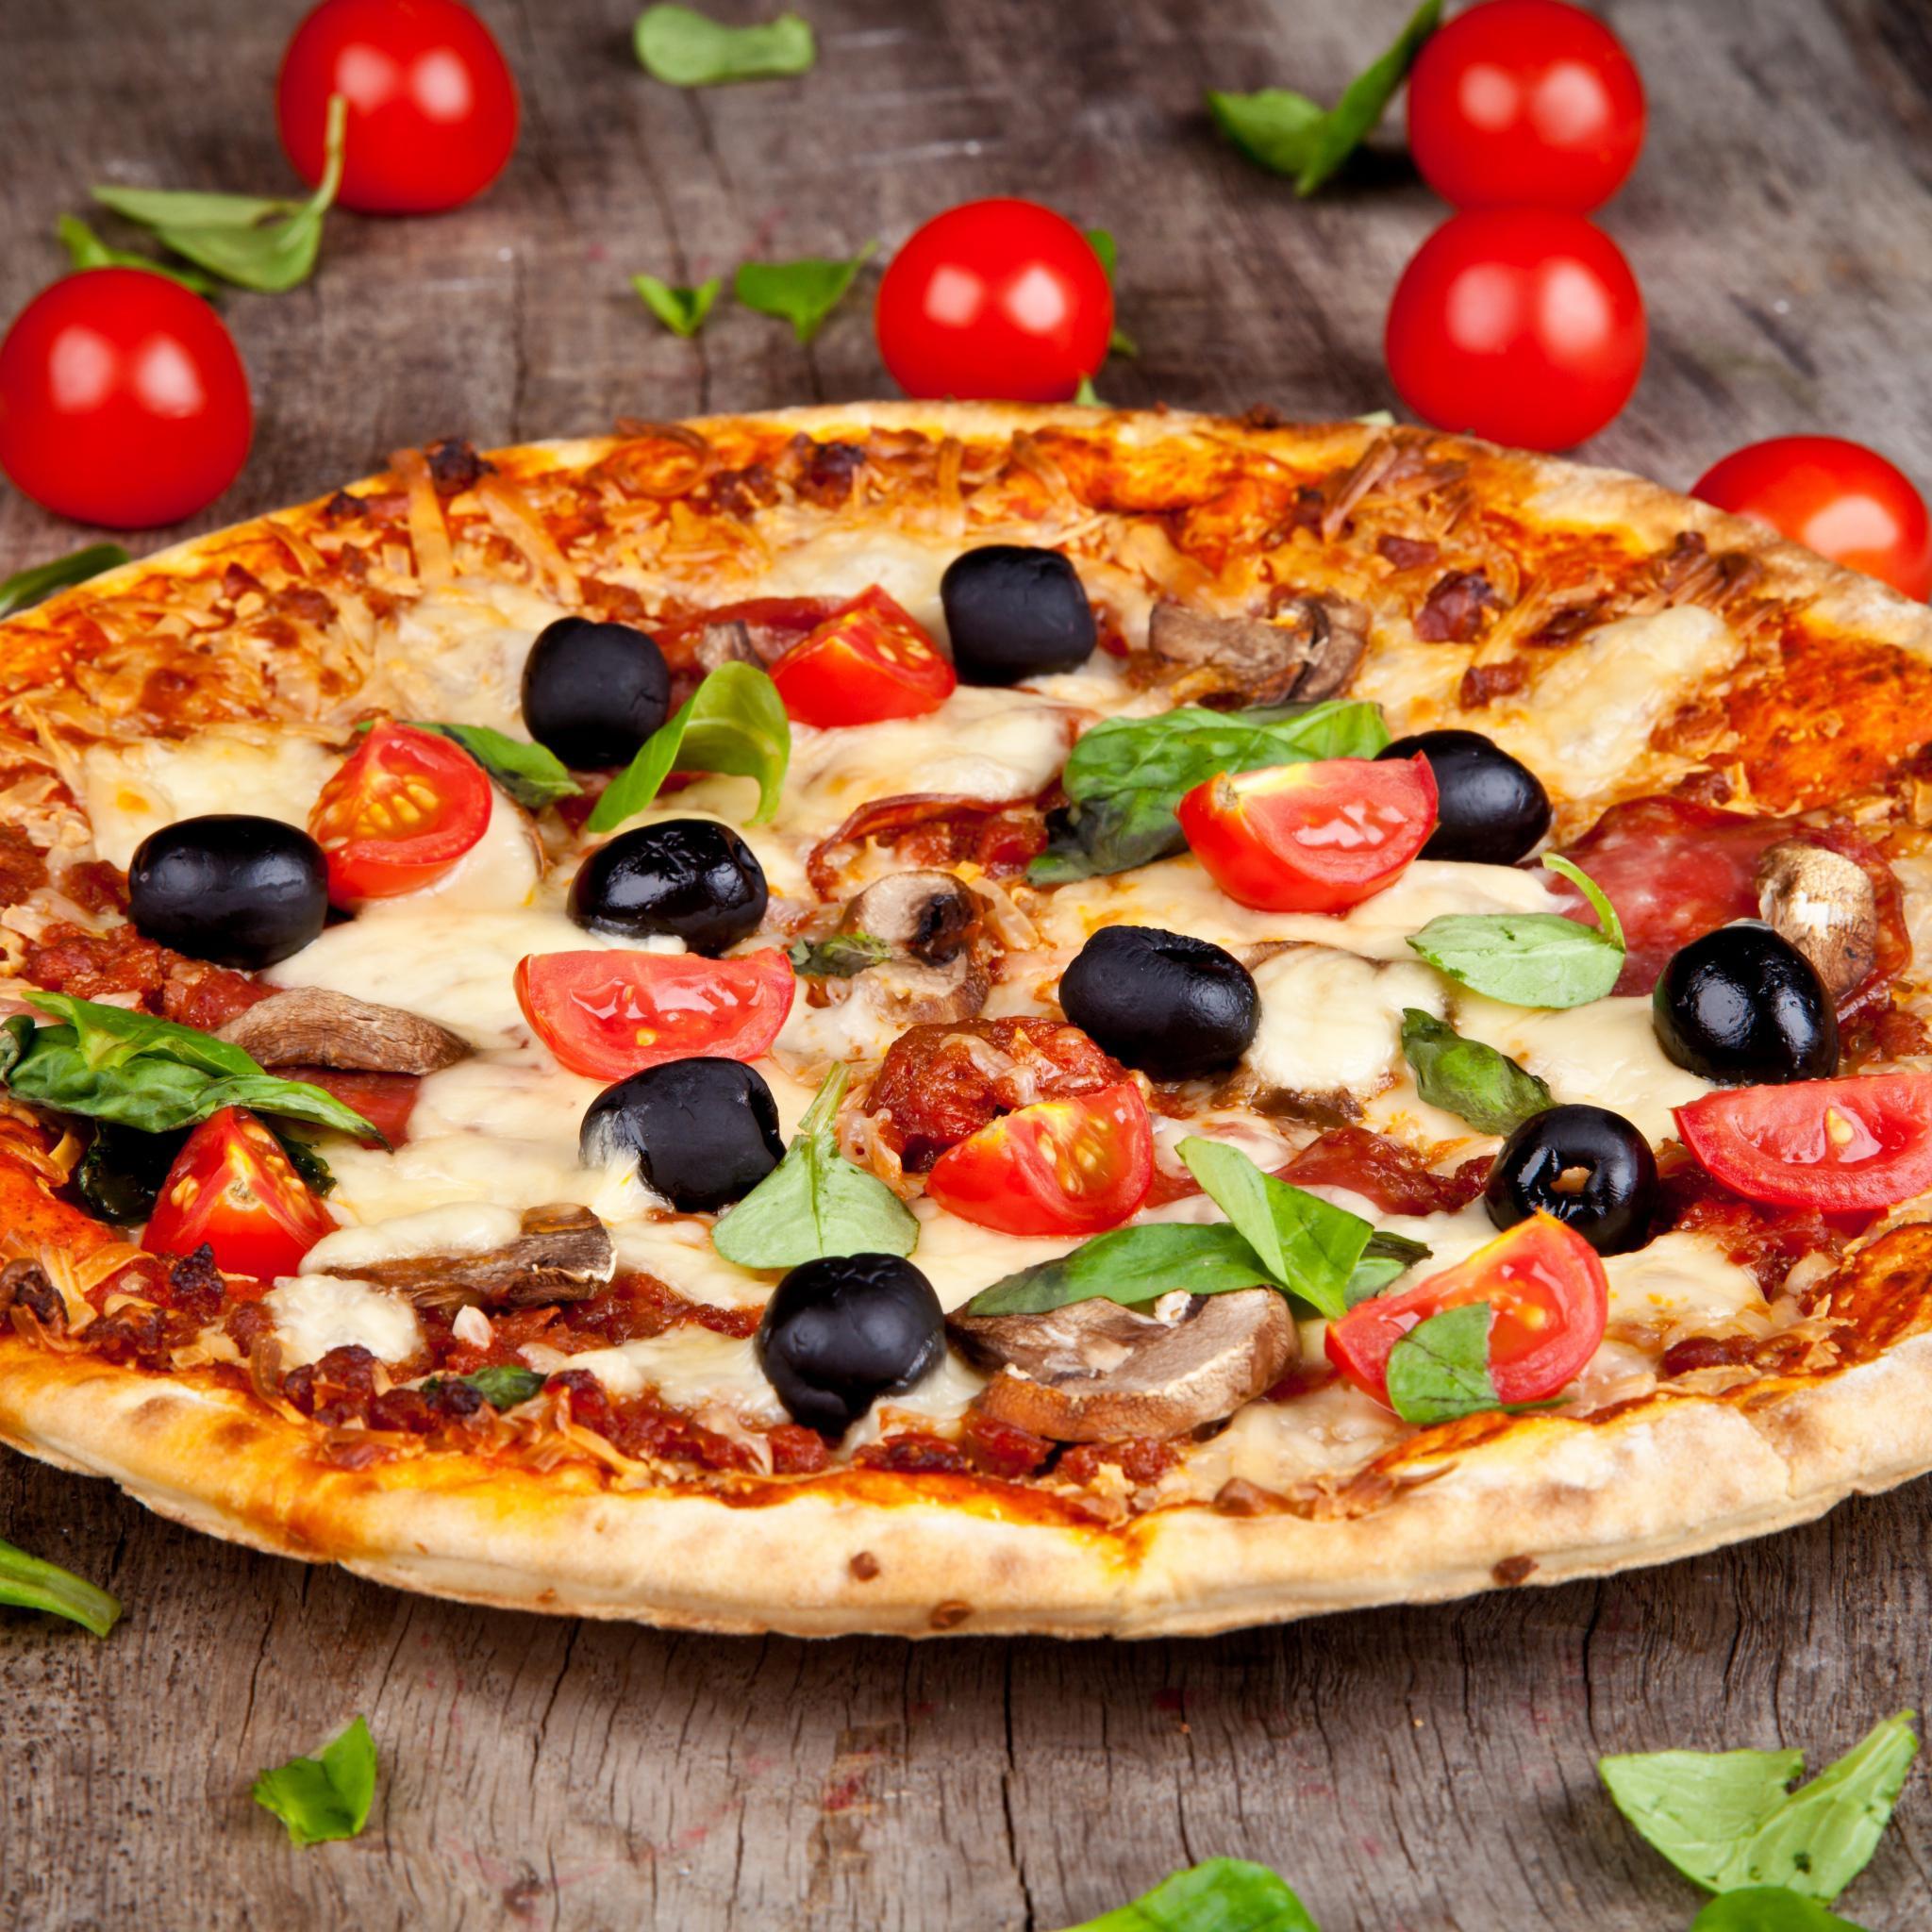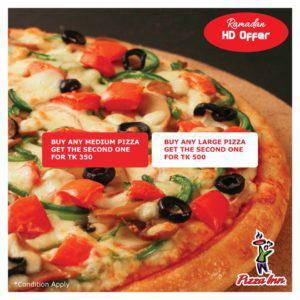The first image is the image on the left, the second image is the image on the right. Analyze the images presented: Is the assertion "The yellow yolk of an egg and pieces of tomato can be seen among the toppings on a baked pizza in one image" valid? Answer yes or no. No. The first image is the image on the left, the second image is the image on the right. For the images displayed, is the sentence "All of the pizzas have been sliced." factually correct? Answer yes or no. No. 